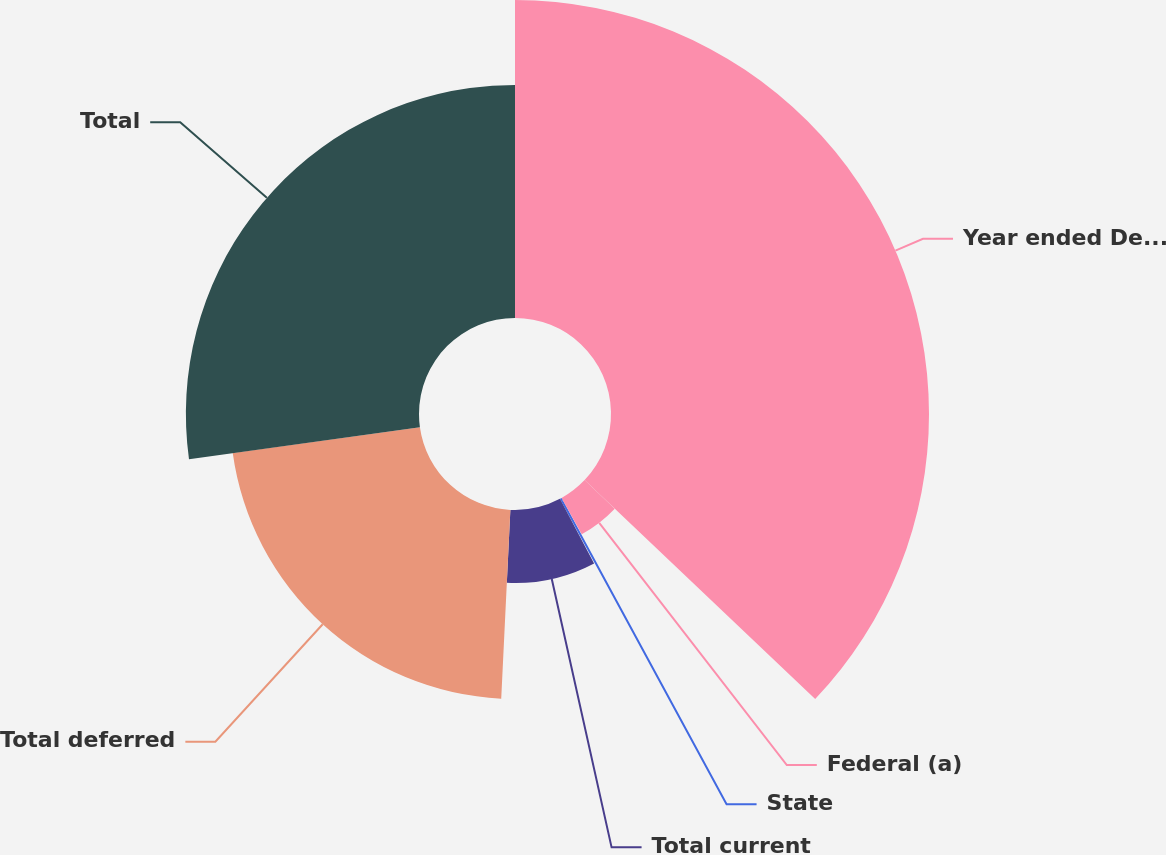<chart> <loc_0><loc_0><loc_500><loc_500><pie_chart><fcel>Year ended December 31 In<fcel>Federal (a)<fcel>State<fcel>Total current<fcel>Total deferred<fcel>Total<nl><fcel>37.09%<fcel>4.85%<fcel>0.31%<fcel>8.52%<fcel>22.04%<fcel>27.19%<nl></chart> 